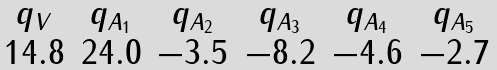Convert formula to latex. <formula><loc_0><loc_0><loc_500><loc_500>\begin{array} { c c c c c c } { { q _ { V } } } & { { q _ { A _ { 1 } } } } & { { q _ { A _ { 2 } } } } & { { q _ { A _ { 3 } } } } & { { q _ { A _ { 4 } } } } & { { q _ { A _ { 5 } } } } \\ { { 1 4 . 8 } } & { 2 4 . 0 } & { - 3 . 5 } & { - 8 . 2 } & { - 4 . 6 } & { - 2 . 7 } \end{array}</formula> 